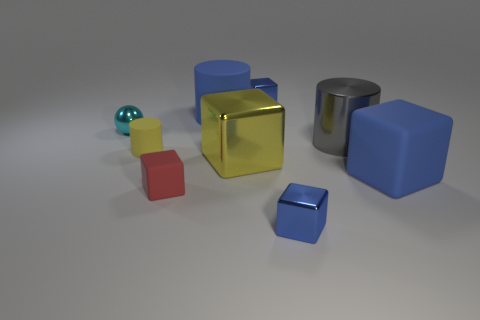Are there any other things that are the same shape as the tiny cyan metallic object?
Provide a short and direct response. No. How many small metal things are the same shape as the large yellow metallic object?
Make the answer very short. 2. There is a small thing that is right of the big blue matte cylinder and in front of the metal sphere; what color is it?
Your answer should be very brief. Blue. How many gray shiny things are there?
Provide a succinct answer. 1. Do the yellow matte thing and the gray metallic object have the same size?
Offer a terse response. No. Are there any cubes that have the same color as the large rubber cylinder?
Provide a succinct answer. Yes. There is a yellow thing that is on the right side of the blue cylinder; does it have the same shape as the red matte object?
Provide a short and direct response. Yes. How many blue rubber objects are the same size as the yellow cylinder?
Make the answer very short. 0. There is a tiny metal object that is in front of the big rubber block; what number of blue matte cubes are on the left side of it?
Provide a short and direct response. 0. Are the tiny blue thing that is behind the small cylinder and the large blue cube made of the same material?
Offer a very short reply. No. 